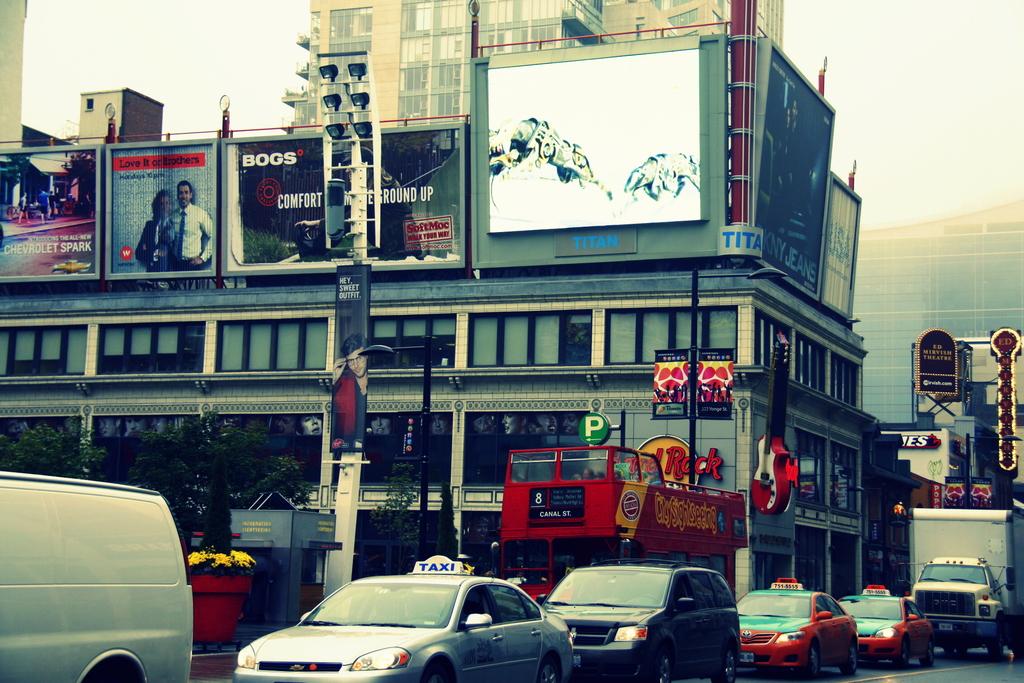What is the route number of the red bus?
Keep it short and to the point. 8. 